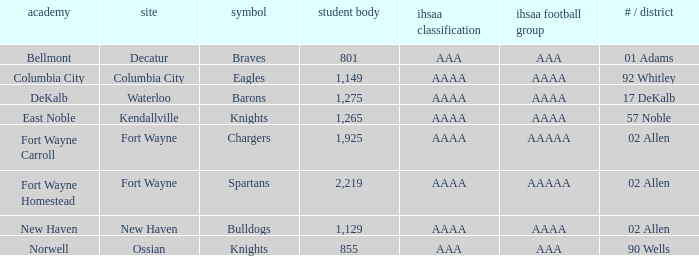What school has a mascot of the spartans with an AAAA IHSAA class and more than 1,275 enrolled? Fort Wayne Homestead. 